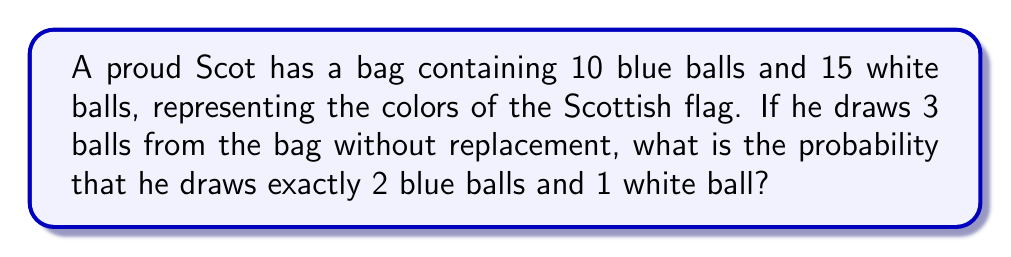Can you answer this question? Let's approach this step-by-step:

1) First, we need to calculate the total number of ways to draw 3 balls from 25 balls. This can be done using the combination formula:

   $$\binom{25}{3} = \frac{25!}{3!(25-3)!} = \frac{25!}{3!22!} = 2300$$

2) Now, we need to calculate the number of ways to draw 2 blue balls and 1 white ball. This can be broken down into:
   - Ways to choose 2 blue balls from 10 blue balls: $\binom{10}{2}$
   - Ways to choose 1 white ball from 15 white balls: $\binom{15}{1}$

3) Let's calculate these:

   $$\binom{10}{2} = \frac{10!}{2!8!} = 45$$
   $$\binom{15}{1} = 15$$

4) The total number of favorable outcomes is the product of these:

   $$45 \times 15 = 675$$

5) The probability is the number of favorable outcomes divided by the total number of possible outcomes:

   $$P(\text{2 blue, 1 white}) = \frac{675}{2300}$$

6) This can be simplified:

   $$\frac{675}{2300} = \frac{27}{92} \approx 0.2935$$
Answer: The probability of drawing exactly 2 blue balls and 1 white ball is $\frac{27}{92}$ or approximately 0.2935 (29.35%). 